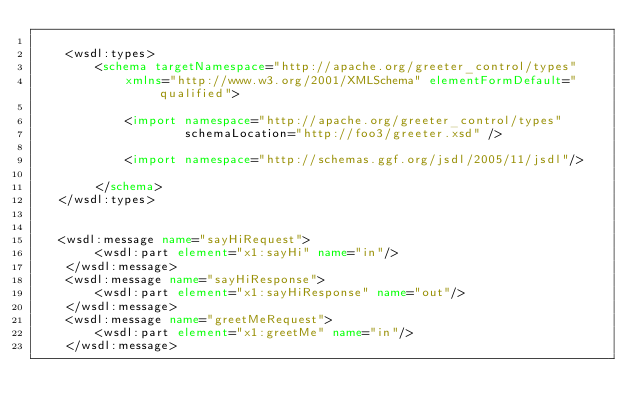Convert code to text. <code><loc_0><loc_0><loc_500><loc_500><_XML_>
    <wsdl:types>
        <schema targetNamespace="http://apache.org/greeter_control/types" 
            xmlns="http://www.w3.org/2001/XMLSchema" elementFormDefault="qualified">

            <import namespace="http://apache.org/greeter_control/types" 
                    schemaLocation="http://foo3/greeter.xsd" />

            <import namespace="http://schemas.ggf.org/jsdl/2005/11/jsdl"/>
            
        </schema>
   </wsdl:types>

   
   <wsdl:message name="sayHiRequest">
        <wsdl:part element="x1:sayHi" name="in"/>
    </wsdl:message>
    <wsdl:message name="sayHiResponse">
        <wsdl:part element="x1:sayHiResponse" name="out"/>
    </wsdl:message>
    <wsdl:message name="greetMeRequest">
        <wsdl:part element="x1:greetMe" name="in"/>
    </wsdl:message></code> 